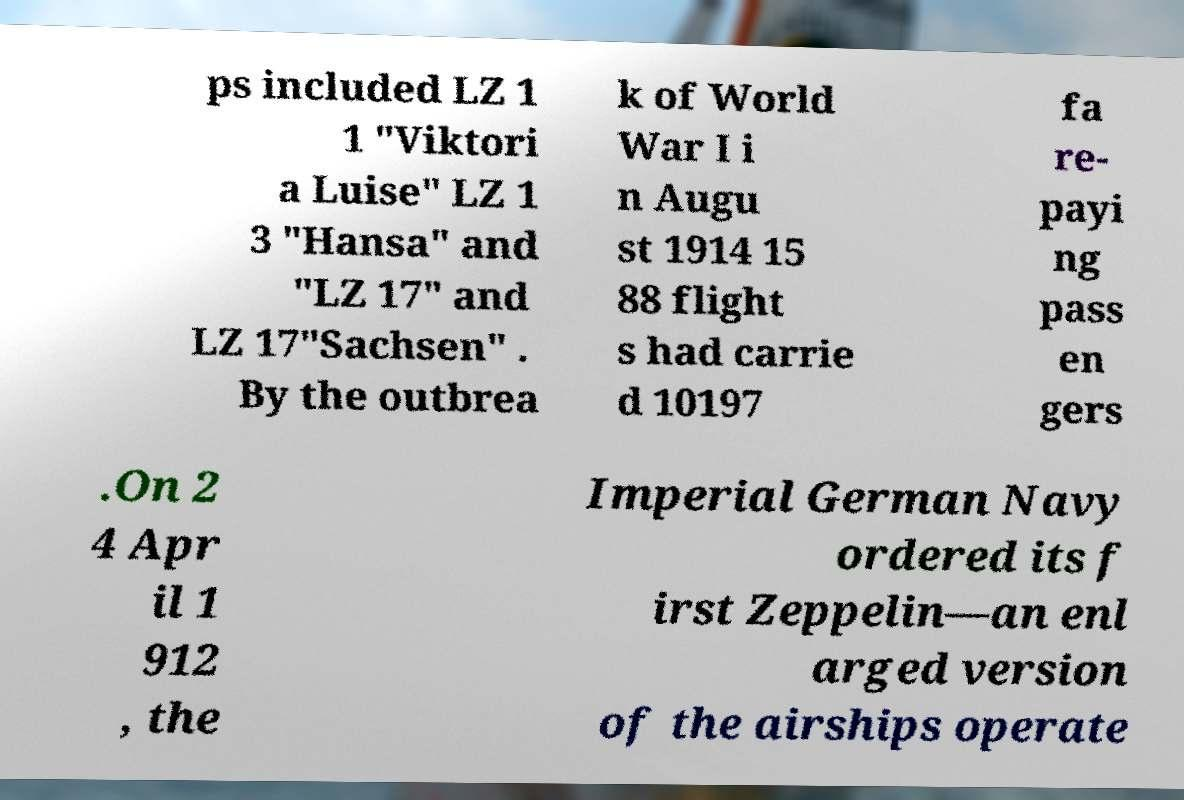Could you extract and type out the text from this image? ps included LZ 1 1 "Viktori a Luise" LZ 1 3 "Hansa" and "LZ 17" and LZ 17"Sachsen" . By the outbrea k of World War I i n Augu st 1914 15 88 flight s had carrie d 10197 fa re- payi ng pass en gers .On 2 4 Apr il 1 912 , the Imperial German Navy ordered its f irst Zeppelin—an enl arged version of the airships operate 